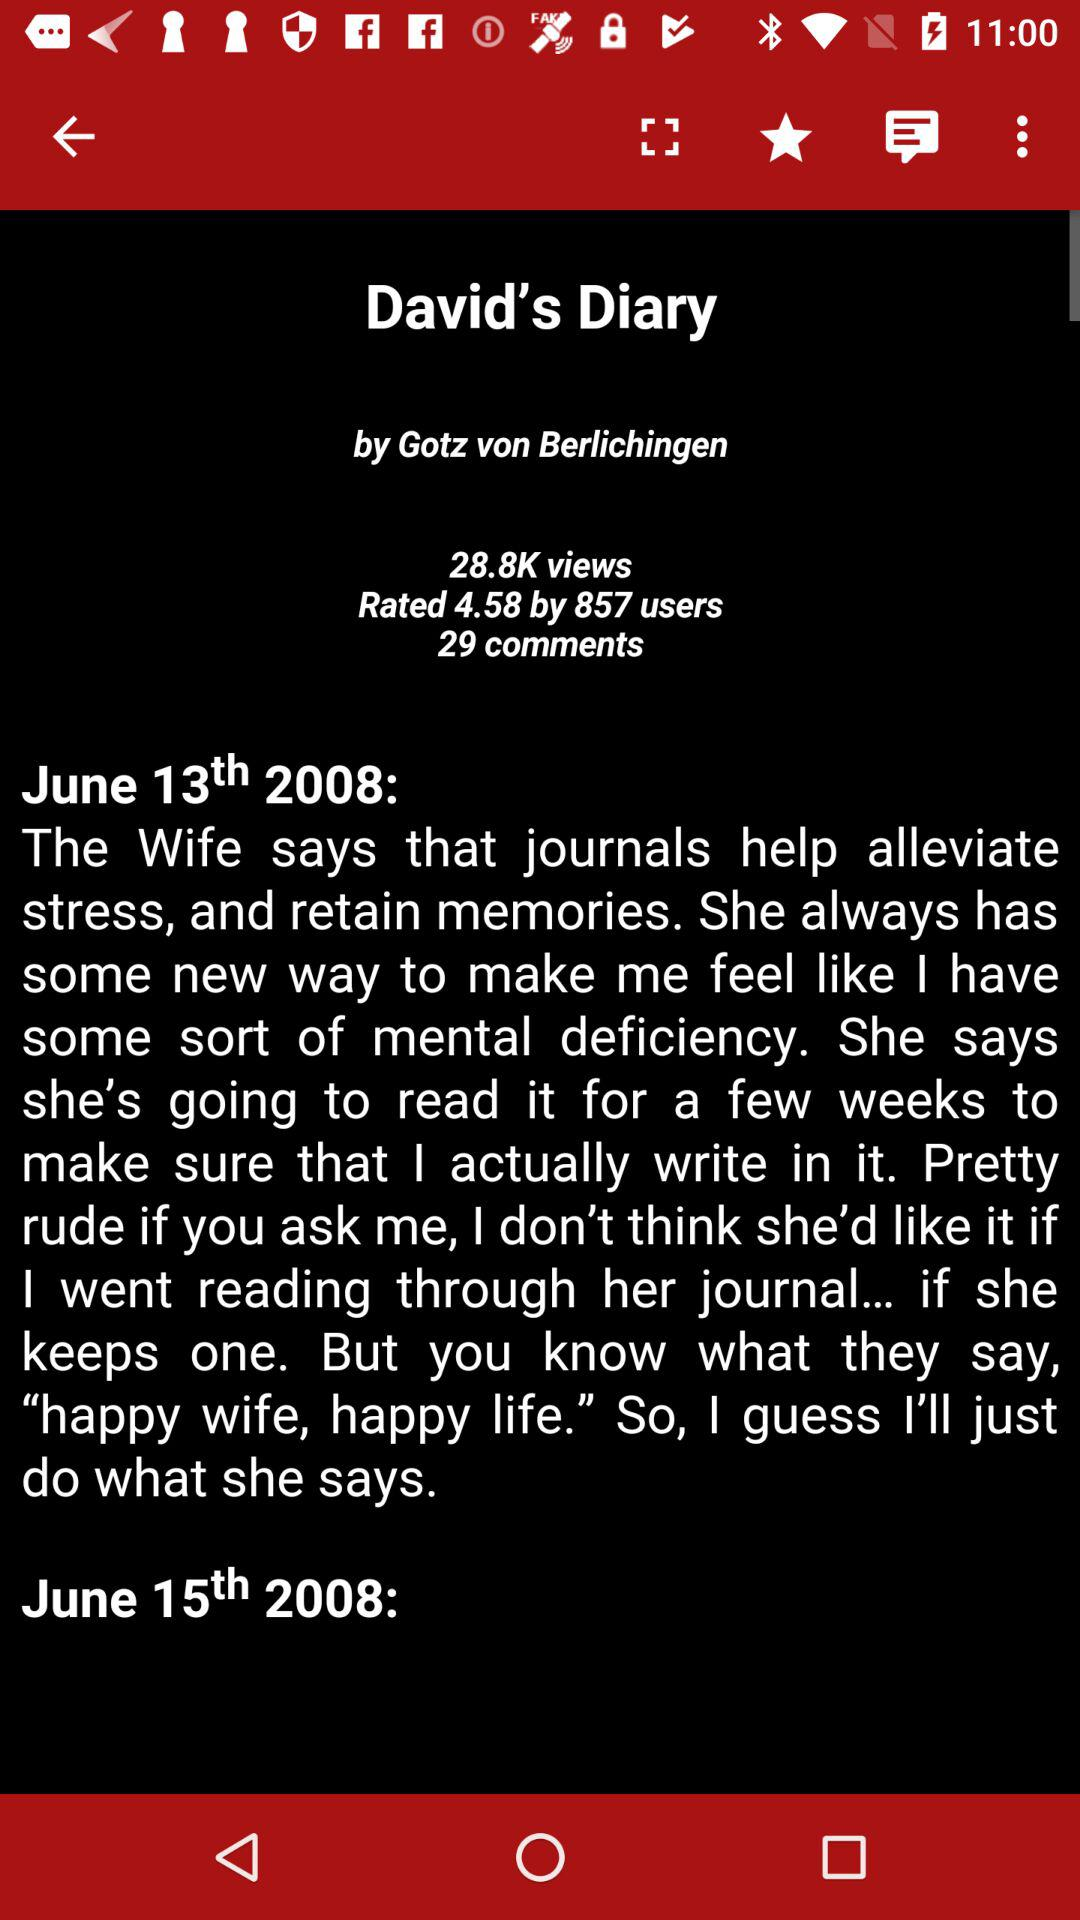How many days are in the diary?
Answer the question using a single word or phrase. 2 